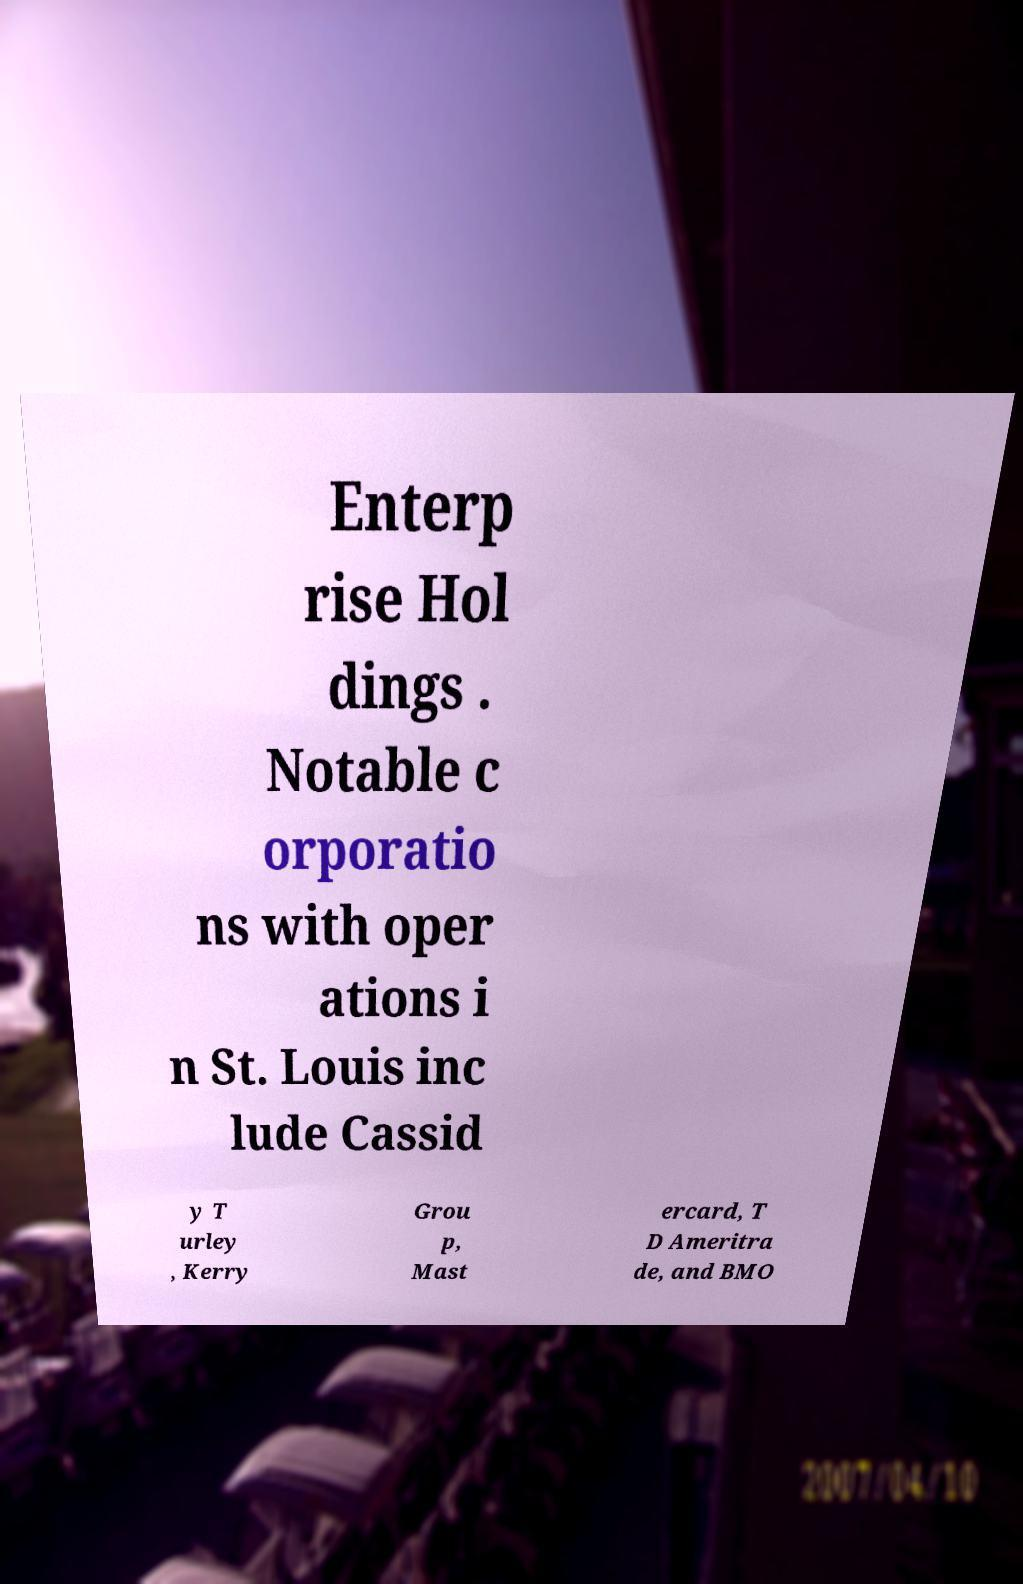Could you assist in decoding the text presented in this image and type it out clearly? Enterp rise Hol dings . Notable c orporatio ns with oper ations i n St. Louis inc lude Cassid y T urley , Kerry Grou p, Mast ercard, T D Ameritra de, and BMO 